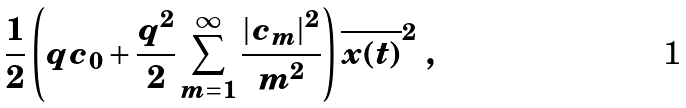Convert formula to latex. <formula><loc_0><loc_0><loc_500><loc_500>\frac { 1 } { 2 } \left ( q c _ { 0 } + \frac { q ^ { 2 } } { 2 } \sum _ { m = 1 } ^ { \infty } \frac { | c _ { m } | ^ { 2 } } { m ^ { 2 } } \right ) \overline { x ( t ) } ^ { 2 } \ ,</formula> 